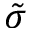Convert formula to latex. <formula><loc_0><loc_0><loc_500><loc_500>\tilde { \sigma }</formula> 